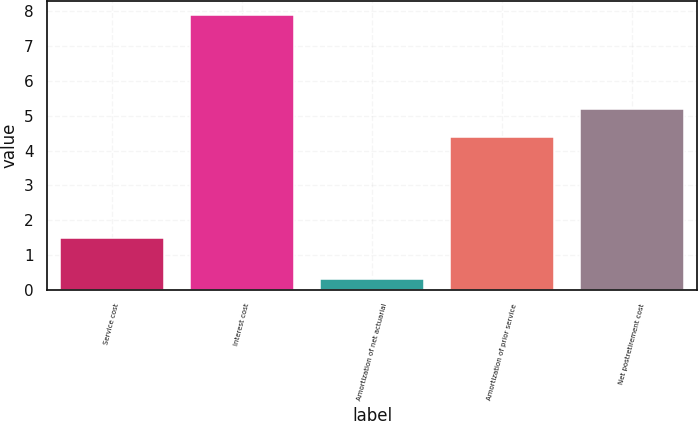<chart> <loc_0><loc_0><loc_500><loc_500><bar_chart><fcel>Service cost<fcel>Interest cost<fcel>Amortization of net actuarial<fcel>Amortization of prior service<fcel>Net postretirement cost<nl><fcel>1.5<fcel>7.9<fcel>0.3<fcel>4.4<fcel>5.2<nl></chart> 